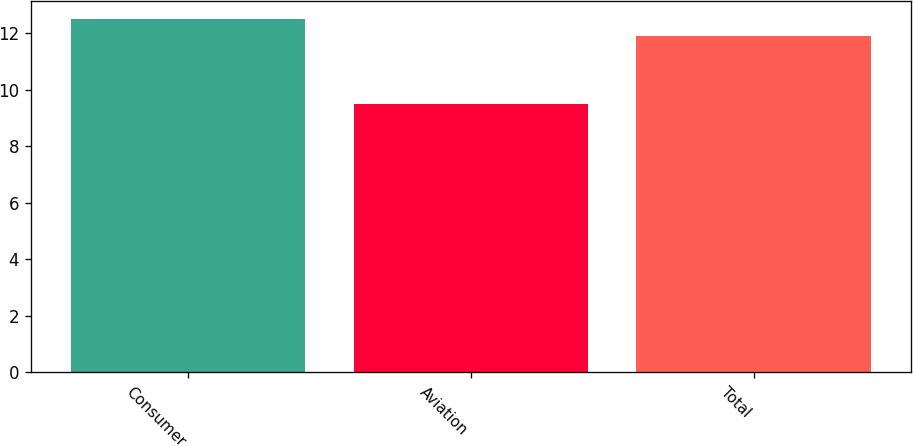<chart> <loc_0><loc_0><loc_500><loc_500><bar_chart><fcel>Consumer<fcel>Aviation<fcel>Total<nl><fcel>12.5<fcel>9.5<fcel>11.9<nl></chart> 